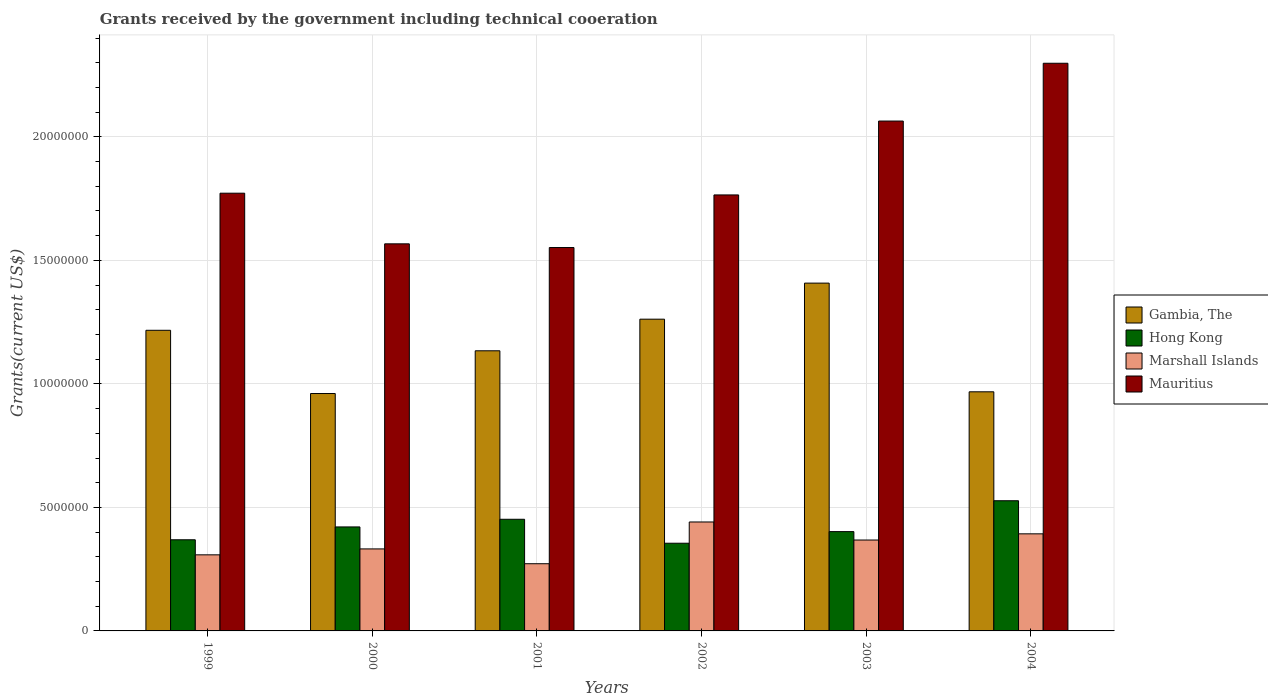Are the number of bars per tick equal to the number of legend labels?
Your response must be concise. Yes. How many bars are there on the 6th tick from the left?
Offer a terse response. 4. How many bars are there on the 6th tick from the right?
Your answer should be very brief. 4. In how many cases, is the number of bars for a given year not equal to the number of legend labels?
Keep it short and to the point. 0. What is the total grants received by the government in Mauritius in 2002?
Make the answer very short. 1.76e+07. Across all years, what is the maximum total grants received by the government in Mauritius?
Give a very brief answer. 2.30e+07. Across all years, what is the minimum total grants received by the government in Marshall Islands?
Your response must be concise. 2.72e+06. In which year was the total grants received by the government in Hong Kong minimum?
Offer a very short reply. 2002. What is the total total grants received by the government in Gambia, The in the graph?
Make the answer very short. 6.95e+07. What is the difference between the total grants received by the government in Hong Kong in 1999 and that in 2001?
Provide a succinct answer. -8.30e+05. What is the difference between the total grants received by the government in Marshall Islands in 2000 and the total grants received by the government in Gambia, The in 2004?
Your answer should be very brief. -6.36e+06. What is the average total grants received by the government in Gambia, The per year?
Offer a terse response. 1.16e+07. In the year 2003, what is the difference between the total grants received by the government in Gambia, The and total grants received by the government in Hong Kong?
Make the answer very short. 1.01e+07. In how many years, is the total grants received by the government in Mauritius greater than 17000000 US$?
Your answer should be compact. 4. What is the ratio of the total grants received by the government in Gambia, The in 2002 to that in 2003?
Provide a short and direct response. 0.9. What is the difference between the highest and the second highest total grants received by the government in Hong Kong?
Your answer should be compact. 7.50e+05. What is the difference between the highest and the lowest total grants received by the government in Hong Kong?
Provide a succinct answer. 1.72e+06. In how many years, is the total grants received by the government in Gambia, The greater than the average total grants received by the government in Gambia, The taken over all years?
Offer a terse response. 3. Is it the case that in every year, the sum of the total grants received by the government in Hong Kong and total grants received by the government in Mauritius is greater than the sum of total grants received by the government in Gambia, The and total grants received by the government in Marshall Islands?
Offer a very short reply. Yes. What does the 1st bar from the left in 1999 represents?
Offer a terse response. Gambia, The. What does the 4th bar from the right in 2001 represents?
Your answer should be very brief. Gambia, The. Is it the case that in every year, the sum of the total grants received by the government in Gambia, The and total grants received by the government in Marshall Islands is greater than the total grants received by the government in Mauritius?
Ensure brevity in your answer.  No. What is the difference between two consecutive major ticks on the Y-axis?
Offer a very short reply. 5.00e+06. Does the graph contain any zero values?
Ensure brevity in your answer.  No. Where does the legend appear in the graph?
Ensure brevity in your answer.  Center right. How are the legend labels stacked?
Give a very brief answer. Vertical. What is the title of the graph?
Your response must be concise. Grants received by the government including technical cooeration. Does "High income" appear as one of the legend labels in the graph?
Make the answer very short. No. What is the label or title of the X-axis?
Provide a succinct answer. Years. What is the label or title of the Y-axis?
Offer a terse response. Grants(current US$). What is the Grants(current US$) of Gambia, The in 1999?
Make the answer very short. 1.22e+07. What is the Grants(current US$) of Hong Kong in 1999?
Your response must be concise. 3.69e+06. What is the Grants(current US$) of Marshall Islands in 1999?
Offer a terse response. 3.08e+06. What is the Grants(current US$) in Mauritius in 1999?
Make the answer very short. 1.77e+07. What is the Grants(current US$) of Gambia, The in 2000?
Your answer should be very brief. 9.61e+06. What is the Grants(current US$) in Hong Kong in 2000?
Your answer should be compact. 4.21e+06. What is the Grants(current US$) of Marshall Islands in 2000?
Provide a short and direct response. 3.32e+06. What is the Grants(current US$) of Mauritius in 2000?
Your answer should be compact. 1.57e+07. What is the Grants(current US$) of Gambia, The in 2001?
Give a very brief answer. 1.13e+07. What is the Grants(current US$) in Hong Kong in 2001?
Your answer should be compact. 4.52e+06. What is the Grants(current US$) of Marshall Islands in 2001?
Keep it short and to the point. 2.72e+06. What is the Grants(current US$) of Mauritius in 2001?
Your response must be concise. 1.55e+07. What is the Grants(current US$) in Gambia, The in 2002?
Give a very brief answer. 1.26e+07. What is the Grants(current US$) of Hong Kong in 2002?
Your response must be concise. 3.55e+06. What is the Grants(current US$) of Marshall Islands in 2002?
Offer a terse response. 4.41e+06. What is the Grants(current US$) of Mauritius in 2002?
Your answer should be very brief. 1.76e+07. What is the Grants(current US$) of Gambia, The in 2003?
Make the answer very short. 1.41e+07. What is the Grants(current US$) in Hong Kong in 2003?
Make the answer very short. 4.02e+06. What is the Grants(current US$) in Marshall Islands in 2003?
Offer a terse response. 3.68e+06. What is the Grants(current US$) in Mauritius in 2003?
Keep it short and to the point. 2.06e+07. What is the Grants(current US$) in Gambia, The in 2004?
Provide a succinct answer. 9.68e+06. What is the Grants(current US$) in Hong Kong in 2004?
Make the answer very short. 5.27e+06. What is the Grants(current US$) of Marshall Islands in 2004?
Keep it short and to the point. 3.93e+06. What is the Grants(current US$) of Mauritius in 2004?
Your answer should be compact. 2.30e+07. Across all years, what is the maximum Grants(current US$) in Gambia, The?
Your answer should be very brief. 1.41e+07. Across all years, what is the maximum Grants(current US$) of Hong Kong?
Give a very brief answer. 5.27e+06. Across all years, what is the maximum Grants(current US$) of Marshall Islands?
Your answer should be very brief. 4.41e+06. Across all years, what is the maximum Grants(current US$) in Mauritius?
Provide a succinct answer. 2.30e+07. Across all years, what is the minimum Grants(current US$) in Gambia, The?
Ensure brevity in your answer.  9.61e+06. Across all years, what is the minimum Grants(current US$) in Hong Kong?
Give a very brief answer. 3.55e+06. Across all years, what is the minimum Grants(current US$) in Marshall Islands?
Ensure brevity in your answer.  2.72e+06. Across all years, what is the minimum Grants(current US$) of Mauritius?
Offer a very short reply. 1.55e+07. What is the total Grants(current US$) of Gambia, The in the graph?
Make the answer very short. 6.95e+07. What is the total Grants(current US$) in Hong Kong in the graph?
Provide a succinct answer. 2.53e+07. What is the total Grants(current US$) of Marshall Islands in the graph?
Ensure brevity in your answer.  2.11e+07. What is the total Grants(current US$) of Mauritius in the graph?
Your answer should be very brief. 1.10e+08. What is the difference between the Grants(current US$) in Gambia, The in 1999 and that in 2000?
Make the answer very short. 2.56e+06. What is the difference between the Grants(current US$) in Hong Kong in 1999 and that in 2000?
Your answer should be compact. -5.20e+05. What is the difference between the Grants(current US$) of Mauritius in 1999 and that in 2000?
Your answer should be compact. 2.05e+06. What is the difference between the Grants(current US$) in Gambia, The in 1999 and that in 2001?
Offer a very short reply. 8.30e+05. What is the difference between the Grants(current US$) in Hong Kong in 1999 and that in 2001?
Provide a succinct answer. -8.30e+05. What is the difference between the Grants(current US$) of Mauritius in 1999 and that in 2001?
Keep it short and to the point. 2.20e+06. What is the difference between the Grants(current US$) in Gambia, The in 1999 and that in 2002?
Ensure brevity in your answer.  -4.50e+05. What is the difference between the Grants(current US$) of Hong Kong in 1999 and that in 2002?
Make the answer very short. 1.40e+05. What is the difference between the Grants(current US$) in Marshall Islands in 1999 and that in 2002?
Your answer should be very brief. -1.33e+06. What is the difference between the Grants(current US$) of Mauritius in 1999 and that in 2002?
Keep it short and to the point. 7.00e+04. What is the difference between the Grants(current US$) in Gambia, The in 1999 and that in 2003?
Offer a terse response. -1.91e+06. What is the difference between the Grants(current US$) of Hong Kong in 1999 and that in 2003?
Your answer should be compact. -3.30e+05. What is the difference between the Grants(current US$) in Marshall Islands in 1999 and that in 2003?
Your answer should be very brief. -6.00e+05. What is the difference between the Grants(current US$) of Mauritius in 1999 and that in 2003?
Provide a succinct answer. -2.92e+06. What is the difference between the Grants(current US$) in Gambia, The in 1999 and that in 2004?
Your answer should be compact. 2.49e+06. What is the difference between the Grants(current US$) in Hong Kong in 1999 and that in 2004?
Give a very brief answer. -1.58e+06. What is the difference between the Grants(current US$) of Marshall Islands in 1999 and that in 2004?
Provide a short and direct response. -8.50e+05. What is the difference between the Grants(current US$) of Mauritius in 1999 and that in 2004?
Your answer should be very brief. -5.26e+06. What is the difference between the Grants(current US$) of Gambia, The in 2000 and that in 2001?
Provide a short and direct response. -1.73e+06. What is the difference between the Grants(current US$) in Hong Kong in 2000 and that in 2001?
Give a very brief answer. -3.10e+05. What is the difference between the Grants(current US$) in Marshall Islands in 2000 and that in 2001?
Keep it short and to the point. 6.00e+05. What is the difference between the Grants(current US$) of Mauritius in 2000 and that in 2001?
Give a very brief answer. 1.50e+05. What is the difference between the Grants(current US$) in Gambia, The in 2000 and that in 2002?
Make the answer very short. -3.01e+06. What is the difference between the Grants(current US$) in Marshall Islands in 2000 and that in 2002?
Your answer should be compact. -1.09e+06. What is the difference between the Grants(current US$) in Mauritius in 2000 and that in 2002?
Keep it short and to the point. -1.98e+06. What is the difference between the Grants(current US$) in Gambia, The in 2000 and that in 2003?
Offer a very short reply. -4.47e+06. What is the difference between the Grants(current US$) in Marshall Islands in 2000 and that in 2003?
Ensure brevity in your answer.  -3.60e+05. What is the difference between the Grants(current US$) of Mauritius in 2000 and that in 2003?
Your answer should be compact. -4.97e+06. What is the difference between the Grants(current US$) of Hong Kong in 2000 and that in 2004?
Provide a succinct answer. -1.06e+06. What is the difference between the Grants(current US$) in Marshall Islands in 2000 and that in 2004?
Give a very brief answer. -6.10e+05. What is the difference between the Grants(current US$) of Mauritius in 2000 and that in 2004?
Offer a very short reply. -7.31e+06. What is the difference between the Grants(current US$) of Gambia, The in 2001 and that in 2002?
Keep it short and to the point. -1.28e+06. What is the difference between the Grants(current US$) in Hong Kong in 2001 and that in 2002?
Provide a succinct answer. 9.70e+05. What is the difference between the Grants(current US$) in Marshall Islands in 2001 and that in 2002?
Make the answer very short. -1.69e+06. What is the difference between the Grants(current US$) of Mauritius in 2001 and that in 2002?
Your response must be concise. -2.13e+06. What is the difference between the Grants(current US$) of Gambia, The in 2001 and that in 2003?
Your answer should be very brief. -2.74e+06. What is the difference between the Grants(current US$) in Marshall Islands in 2001 and that in 2003?
Keep it short and to the point. -9.60e+05. What is the difference between the Grants(current US$) in Mauritius in 2001 and that in 2003?
Provide a short and direct response. -5.12e+06. What is the difference between the Grants(current US$) of Gambia, The in 2001 and that in 2004?
Offer a very short reply. 1.66e+06. What is the difference between the Grants(current US$) in Hong Kong in 2001 and that in 2004?
Your response must be concise. -7.50e+05. What is the difference between the Grants(current US$) in Marshall Islands in 2001 and that in 2004?
Your response must be concise. -1.21e+06. What is the difference between the Grants(current US$) of Mauritius in 2001 and that in 2004?
Your answer should be very brief. -7.46e+06. What is the difference between the Grants(current US$) of Gambia, The in 2002 and that in 2003?
Your response must be concise. -1.46e+06. What is the difference between the Grants(current US$) of Hong Kong in 2002 and that in 2003?
Your answer should be very brief. -4.70e+05. What is the difference between the Grants(current US$) of Marshall Islands in 2002 and that in 2003?
Your answer should be very brief. 7.30e+05. What is the difference between the Grants(current US$) in Mauritius in 2002 and that in 2003?
Give a very brief answer. -2.99e+06. What is the difference between the Grants(current US$) in Gambia, The in 2002 and that in 2004?
Make the answer very short. 2.94e+06. What is the difference between the Grants(current US$) in Hong Kong in 2002 and that in 2004?
Provide a short and direct response. -1.72e+06. What is the difference between the Grants(current US$) of Mauritius in 2002 and that in 2004?
Provide a succinct answer. -5.33e+06. What is the difference between the Grants(current US$) of Gambia, The in 2003 and that in 2004?
Keep it short and to the point. 4.40e+06. What is the difference between the Grants(current US$) in Hong Kong in 2003 and that in 2004?
Your answer should be compact. -1.25e+06. What is the difference between the Grants(current US$) in Marshall Islands in 2003 and that in 2004?
Your response must be concise. -2.50e+05. What is the difference between the Grants(current US$) in Mauritius in 2003 and that in 2004?
Keep it short and to the point. -2.34e+06. What is the difference between the Grants(current US$) in Gambia, The in 1999 and the Grants(current US$) in Hong Kong in 2000?
Your answer should be compact. 7.96e+06. What is the difference between the Grants(current US$) in Gambia, The in 1999 and the Grants(current US$) in Marshall Islands in 2000?
Give a very brief answer. 8.85e+06. What is the difference between the Grants(current US$) in Gambia, The in 1999 and the Grants(current US$) in Mauritius in 2000?
Ensure brevity in your answer.  -3.50e+06. What is the difference between the Grants(current US$) in Hong Kong in 1999 and the Grants(current US$) in Marshall Islands in 2000?
Provide a short and direct response. 3.70e+05. What is the difference between the Grants(current US$) in Hong Kong in 1999 and the Grants(current US$) in Mauritius in 2000?
Provide a succinct answer. -1.20e+07. What is the difference between the Grants(current US$) of Marshall Islands in 1999 and the Grants(current US$) of Mauritius in 2000?
Your answer should be very brief. -1.26e+07. What is the difference between the Grants(current US$) in Gambia, The in 1999 and the Grants(current US$) in Hong Kong in 2001?
Make the answer very short. 7.65e+06. What is the difference between the Grants(current US$) in Gambia, The in 1999 and the Grants(current US$) in Marshall Islands in 2001?
Offer a very short reply. 9.45e+06. What is the difference between the Grants(current US$) in Gambia, The in 1999 and the Grants(current US$) in Mauritius in 2001?
Provide a short and direct response. -3.35e+06. What is the difference between the Grants(current US$) of Hong Kong in 1999 and the Grants(current US$) of Marshall Islands in 2001?
Offer a terse response. 9.70e+05. What is the difference between the Grants(current US$) in Hong Kong in 1999 and the Grants(current US$) in Mauritius in 2001?
Provide a succinct answer. -1.18e+07. What is the difference between the Grants(current US$) in Marshall Islands in 1999 and the Grants(current US$) in Mauritius in 2001?
Your answer should be compact. -1.24e+07. What is the difference between the Grants(current US$) of Gambia, The in 1999 and the Grants(current US$) of Hong Kong in 2002?
Give a very brief answer. 8.62e+06. What is the difference between the Grants(current US$) in Gambia, The in 1999 and the Grants(current US$) in Marshall Islands in 2002?
Your answer should be very brief. 7.76e+06. What is the difference between the Grants(current US$) in Gambia, The in 1999 and the Grants(current US$) in Mauritius in 2002?
Your response must be concise. -5.48e+06. What is the difference between the Grants(current US$) of Hong Kong in 1999 and the Grants(current US$) of Marshall Islands in 2002?
Offer a very short reply. -7.20e+05. What is the difference between the Grants(current US$) in Hong Kong in 1999 and the Grants(current US$) in Mauritius in 2002?
Make the answer very short. -1.40e+07. What is the difference between the Grants(current US$) in Marshall Islands in 1999 and the Grants(current US$) in Mauritius in 2002?
Make the answer very short. -1.46e+07. What is the difference between the Grants(current US$) of Gambia, The in 1999 and the Grants(current US$) of Hong Kong in 2003?
Provide a succinct answer. 8.15e+06. What is the difference between the Grants(current US$) of Gambia, The in 1999 and the Grants(current US$) of Marshall Islands in 2003?
Ensure brevity in your answer.  8.49e+06. What is the difference between the Grants(current US$) in Gambia, The in 1999 and the Grants(current US$) in Mauritius in 2003?
Offer a terse response. -8.47e+06. What is the difference between the Grants(current US$) of Hong Kong in 1999 and the Grants(current US$) of Marshall Islands in 2003?
Offer a very short reply. 10000. What is the difference between the Grants(current US$) in Hong Kong in 1999 and the Grants(current US$) in Mauritius in 2003?
Your answer should be very brief. -1.70e+07. What is the difference between the Grants(current US$) in Marshall Islands in 1999 and the Grants(current US$) in Mauritius in 2003?
Ensure brevity in your answer.  -1.76e+07. What is the difference between the Grants(current US$) in Gambia, The in 1999 and the Grants(current US$) in Hong Kong in 2004?
Provide a short and direct response. 6.90e+06. What is the difference between the Grants(current US$) of Gambia, The in 1999 and the Grants(current US$) of Marshall Islands in 2004?
Provide a short and direct response. 8.24e+06. What is the difference between the Grants(current US$) in Gambia, The in 1999 and the Grants(current US$) in Mauritius in 2004?
Offer a terse response. -1.08e+07. What is the difference between the Grants(current US$) in Hong Kong in 1999 and the Grants(current US$) in Marshall Islands in 2004?
Ensure brevity in your answer.  -2.40e+05. What is the difference between the Grants(current US$) in Hong Kong in 1999 and the Grants(current US$) in Mauritius in 2004?
Offer a very short reply. -1.93e+07. What is the difference between the Grants(current US$) of Marshall Islands in 1999 and the Grants(current US$) of Mauritius in 2004?
Your answer should be compact. -1.99e+07. What is the difference between the Grants(current US$) of Gambia, The in 2000 and the Grants(current US$) of Hong Kong in 2001?
Make the answer very short. 5.09e+06. What is the difference between the Grants(current US$) in Gambia, The in 2000 and the Grants(current US$) in Marshall Islands in 2001?
Keep it short and to the point. 6.89e+06. What is the difference between the Grants(current US$) of Gambia, The in 2000 and the Grants(current US$) of Mauritius in 2001?
Offer a very short reply. -5.91e+06. What is the difference between the Grants(current US$) of Hong Kong in 2000 and the Grants(current US$) of Marshall Islands in 2001?
Give a very brief answer. 1.49e+06. What is the difference between the Grants(current US$) in Hong Kong in 2000 and the Grants(current US$) in Mauritius in 2001?
Your response must be concise. -1.13e+07. What is the difference between the Grants(current US$) of Marshall Islands in 2000 and the Grants(current US$) of Mauritius in 2001?
Your response must be concise. -1.22e+07. What is the difference between the Grants(current US$) of Gambia, The in 2000 and the Grants(current US$) of Hong Kong in 2002?
Offer a very short reply. 6.06e+06. What is the difference between the Grants(current US$) in Gambia, The in 2000 and the Grants(current US$) in Marshall Islands in 2002?
Keep it short and to the point. 5.20e+06. What is the difference between the Grants(current US$) of Gambia, The in 2000 and the Grants(current US$) of Mauritius in 2002?
Make the answer very short. -8.04e+06. What is the difference between the Grants(current US$) of Hong Kong in 2000 and the Grants(current US$) of Marshall Islands in 2002?
Ensure brevity in your answer.  -2.00e+05. What is the difference between the Grants(current US$) in Hong Kong in 2000 and the Grants(current US$) in Mauritius in 2002?
Keep it short and to the point. -1.34e+07. What is the difference between the Grants(current US$) in Marshall Islands in 2000 and the Grants(current US$) in Mauritius in 2002?
Offer a very short reply. -1.43e+07. What is the difference between the Grants(current US$) of Gambia, The in 2000 and the Grants(current US$) of Hong Kong in 2003?
Make the answer very short. 5.59e+06. What is the difference between the Grants(current US$) of Gambia, The in 2000 and the Grants(current US$) of Marshall Islands in 2003?
Ensure brevity in your answer.  5.93e+06. What is the difference between the Grants(current US$) in Gambia, The in 2000 and the Grants(current US$) in Mauritius in 2003?
Offer a terse response. -1.10e+07. What is the difference between the Grants(current US$) of Hong Kong in 2000 and the Grants(current US$) of Marshall Islands in 2003?
Your response must be concise. 5.30e+05. What is the difference between the Grants(current US$) in Hong Kong in 2000 and the Grants(current US$) in Mauritius in 2003?
Your answer should be very brief. -1.64e+07. What is the difference between the Grants(current US$) of Marshall Islands in 2000 and the Grants(current US$) of Mauritius in 2003?
Offer a terse response. -1.73e+07. What is the difference between the Grants(current US$) of Gambia, The in 2000 and the Grants(current US$) of Hong Kong in 2004?
Your answer should be compact. 4.34e+06. What is the difference between the Grants(current US$) of Gambia, The in 2000 and the Grants(current US$) of Marshall Islands in 2004?
Your answer should be very brief. 5.68e+06. What is the difference between the Grants(current US$) of Gambia, The in 2000 and the Grants(current US$) of Mauritius in 2004?
Give a very brief answer. -1.34e+07. What is the difference between the Grants(current US$) of Hong Kong in 2000 and the Grants(current US$) of Marshall Islands in 2004?
Keep it short and to the point. 2.80e+05. What is the difference between the Grants(current US$) in Hong Kong in 2000 and the Grants(current US$) in Mauritius in 2004?
Your answer should be very brief. -1.88e+07. What is the difference between the Grants(current US$) of Marshall Islands in 2000 and the Grants(current US$) of Mauritius in 2004?
Make the answer very short. -1.97e+07. What is the difference between the Grants(current US$) in Gambia, The in 2001 and the Grants(current US$) in Hong Kong in 2002?
Offer a terse response. 7.79e+06. What is the difference between the Grants(current US$) of Gambia, The in 2001 and the Grants(current US$) of Marshall Islands in 2002?
Keep it short and to the point. 6.93e+06. What is the difference between the Grants(current US$) in Gambia, The in 2001 and the Grants(current US$) in Mauritius in 2002?
Provide a succinct answer. -6.31e+06. What is the difference between the Grants(current US$) of Hong Kong in 2001 and the Grants(current US$) of Mauritius in 2002?
Keep it short and to the point. -1.31e+07. What is the difference between the Grants(current US$) of Marshall Islands in 2001 and the Grants(current US$) of Mauritius in 2002?
Keep it short and to the point. -1.49e+07. What is the difference between the Grants(current US$) of Gambia, The in 2001 and the Grants(current US$) of Hong Kong in 2003?
Keep it short and to the point. 7.32e+06. What is the difference between the Grants(current US$) of Gambia, The in 2001 and the Grants(current US$) of Marshall Islands in 2003?
Your response must be concise. 7.66e+06. What is the difference between the Grants(current US$) in Gambia, The in 2001 and the Grants(current US$) in Mauritius in 2003?
Provide a succinct answer. -9.30e+06. What is the difference between the Grants(current US$) in Hong Kong in 2001 and the Grants(current US$) in Marshall Islands in 2003?
Offer a terse response. 8.40e+05. What is the difference between the Grants(current US$) in Hong Kong in 2001 and the Grants(current US$) in Mauritius in 2003?
Offer a very short reply. -1.61e+07. What is the difference between the Grants(current US$) in Marshall Islands in 2001 and the Grants(current US$) in Mauritius in 2003?
Keep it short and to the point. -1.79e+07. What is the difference between the Grants(current US$) of Gambia, The in 2001 and the Grants(current US$) of Hong Kong in 2004?
Provide a short and direct response. 6.07e+06. What is the difference between the Grants(current US$) in Gambia, The in 2001 and the Grants(current US$) in Marshall Islands in 2004?
Provide a short and direct response. 7.41e+06. What is the difference between the Grants(current US$) in Gambia, The in 2001 and the Grants(current US$) in Mauritius in 2004?
Your answer should be very brief. -1.16e+07. What is the difference between the Grants(current US$) of Hong Kong in 2001 and the Grants(current US$) of Marshall Islands in 2004?
Provide a short and direct response. 5.90e+05. What is the difference between the Grants(current US$) of Hong Kong in 2001 and the Grants(current US$) of Mauritius in 2004?
Give a very brief answer. -1.85e+07. What is the difference between the Grants(current US$) in Marshall Islands in 2001 and the Grants(current US$) in Mauritius in 2004?
Offer a very short reply. -2.03e+07. What is the difference between the Grants(current US$) in Gambia, The in 2002 and the Grants(current US$) in Hong Kong in 2003?
Provide a short and direct response. 8.60e+06. What is the difference between the Grants(current US$) of Gambia, The in 2002 and the Grants(current US$) of Marshall Islands in 2003?
Keep it short and to the point. 8.94e+06. What is the difference between the Grants(current US$) in Gambia, The in 2002 and the Grants(current US$) in Mauritius in 2003?
Offer a very short reply. -8.02e+06. What is the difference between the Grants(current US$) of Hong Kong in 2002 and the Grants(current US$) of Marshall Islands in 2003?
Provide a succinct answer. -1.30e+05. What is the difference between the Grants(current US$) of Hong Kong in 2002 and the Grants(current US$) of Mauritius in 2003?
Provide a short and direct response. -1.71e+07. What is the difference between the Grants(current US$) of Marshall Islands in 2002 and the Grants(current US$) of Mauritius in 2003?
Offer a very short reply. -1.62e+07. What is the difference between the Grants(current US$) in Gambia, The in 2002 and the Grants(current US$) in Hong Kong in 2004?
Your answer should be very brief. 7.35e+06. What is the difference between the Grants(current US$) in Gambia, The in 2002 and the Grants(current US$) in Marshall Islands in 2004?
Give a very brief answer. 8.69e+06. What is the difference between the Grants(current US$) in Gambia, The in 2002 and the Grants(current US$) in Mauritius in 2004?
Provide a short and direct response. -1.04e+07. What is the difference between the Grants(current US$) in Hong Kong in 2002 and the Grants(current US$) in Marshall Islands in 2004?
Provide a succinct answer. -3.80e+05. What is the difference between the Grants(current US$) of Hong Kong in 2002 and the Grants(current US$) of Mauritius in 2004?
Offer a terse response. -1.94e+07. What is the difference between the Grants(current US$) of Marshall Islands in 2002 and the Grants(current US$) of Mauritius in 2004?
Offer a terse response. -1.86e+07. What is the difference between the Grants(current US$) of Gambia, The in 2003 and the Grants(current US$) of Hong Kong in 2004?
Your answer should be compact. 8.81e+06. What is the difference between the Grants(current US$) in Gambia, The in 2003 and the Grants(current US$) in Marshall Islands in 2004?
Offer a terse response. 1.02e+07. What is the difference between the Grants(current US$) in Gambia, The in 2003 and the Grants(current US$) in Mauritius in 2004?
Provide a succinct answer. -8.90e+06. What is the difference between the Grants(current US$) in Hong Kong in 2003 and the Grants(current US$) in Mauritius in 2004?
Give a very brief answer. -1.90e+07. What is the difference between the Grants(current US$) of Marshall Islands in 2003 and the Grants(current US$) of Mauritius in 2004?
Offer a very short reply. -1.93e+07. What is the average Grants(current US$) in Gambia, The per year?
Provide a short and direct response. 1.16e+07. What is the average Grants(current US$) in Hong Kong per year?
Ensure brevity in your answer.  4.21e+06. What is the average Grants(current US$) of Marshall Islands per year?
Your answer should be very brief. 3.52e+06. What is the average Grants(current US$) of Mauritius per year?
Offer a terse response. 1.84e+07. In the year 1999, what is the difference between the Grants(current US$) in Gambia, The and Grants(current US$) in Hong Kong?
Offer a terse response. 8.48e+06. In the year 1999, what is the difference between the Grants(current US$) in Gambia, The and Grants(current US$) in Marshall Islands?
Ensure brevity in your answer.  9.09e+06. In the year 1999, what is the difference between the Grants(current US$) in Gambia, The and Grants(current US$) in Mauritius?
Your answer should be very brief. -5.55e+06. In the year 1999, what is the difference between the Grants(current US$) of Hong Kong and Grants(current US$) of Mauritius?
Your response must be concise. -1.40e+07. In the year 1999, what is the difference between the Grants(current US$) in Marshall Islands and Grants(current US$) in Mauritius?
Ensure brevity in your answer.  -1.46e+07. In the year 2000, what is the difference between the Grants(current US$) in Gambia, The and Grants(current US$) in Hong Kong?
Ensure brevity in your answer.  5.40e+06. In the year 2000, what is the difference between the Grants(current US$) in Gambia, The and Grants(current US$) in Marshall Islands?
Your answer should be compact. 6.29e+06. In the year 2000, what is the difference between the Grants(current US$) of Gambia, The and Grants(current US$) of Mauritius?
Make the answer very short. -6.06e+06. In the year 2000, what is the difference between the Grants(current US$) in Hong Kong and Grants(current US$) in Marshall Islands?
Your answer should be compact. 8.90e+05. In the year 2000, what is the difference between the Grants(current US$) of Hong Kong and Grants(current US$) of Mauritius?
Give a very brief answer. -1.15e+07. In the year 2000, what is the difference between the Grants(current US$) in Marshall Islands and Grants(current US$) in Mauritius?
Offer a very short reply. -1.24e+07. In the year 2001, what is the difference between the Grants(current US$) of Gambia, The and Grants(current US$) of Hong Kong?
Offer a very short reply. 6.82e+06. In the year 2001, what is the difference between the Grants(current US$) in Gambia, The and Grants(current US$) in Marshall Islands?
Your answer should be very brief. 8.62e+06. In the year 2001, what is the difference between the Grants(current US$) of Gambia, The and Grants(current US$) of Mauritius?
Your answer should be very brief. -4.18e+06. In the year 2001, what is the difference between the Grants(current US$) in Hong Kong and Grants(current US$) in Marshall Islands?
Ensure brevity in your answer.  1.80e+06. In the year 2001, what is the difference between the Grants(current US$) in Hong Kong and Grants(current US$) in Mauritius?
Your answer should be compact. -1.10e+07. In the year 2001, what is the difference between the Grants(current US$) of Marshall Islands and Grants(current US$) of Mauritius?
Make the answer very short. -1.28e+07. In the year 2002, what is the difference between the Grants(current US$) of Gambia, The and Grants(current US$) of Hong Kong?
Your answer should be very brief. 9.07e+06. In the year 2002, what is the difference between the Grants(current US$) in Gambia, The and Grants(current US$) in Marshall Islands?
Make the answer very short. 8.21e+06. In the year 2002, what is the difference between the Grants(current US$) of Gambia, The and Grants(current US$) of Mauritius?
Ensure brevity in your answer.  -5.03e+06. In the year 2002, what is the difference between the Grants(current US$) of Hong Kong and Grants(current US$) of Marshall Islands?
Provide a succinct answer. -8.60e+05. In the year 2002, what is the difference between the Grants(current US$) in Hong Kong and Grants(current US$) in Mauritius?
Ensure brevity in your answer.  -1.41e+07. In the year 2002, what is the difference between the Grants(current US$) in Marshall Islands and Grants(current US$) in Mauritius?
Your response must be concise. -1.32e+07. In the year 2003, what is the difference between the Grants(current US$) in Gambia, The and Grants(current US$) in Hong Kong?
Provide a succinct answer. 1.01e+07. In the year 2003, what is the difference between the Grants(current US$) of Gambia, The and Grants(current US$) of Marshall Islands?
Give a very brief answer. 1.04e+07. In the year 2003, what is the difference between the Grants(current US$) in Gambia, The and Grants(current US$) in Mauritius?
Give a very brief answer. -6.56e+06. In the year 2003, what is the difference between the Grants(current US$) in Hong Kong and Grants(current US$) in Mauritius?
Your answer should be very brief. -1.66e+07. In the year 2003, what is the difference between the Grants(current US$) in Marshall Islands and Grants(current US$) in Mauritius?
Offer a terse response. -1.70e+07. In the year 2004, what is the difference between the Grants(current US$) of Gambia, The and Grants(current US$) of Hong Kong?
Offer a very short reply. 4.41e+06. In the year 2004, what is the difference between the Grants(current US$) in Gambia, The and Grants(current US$) in Marshall Islands?
Offer a terse response. 5.75e+06. In the year 2004, what is the difference between the Grants(current US$) in Gambia, The and Grants(current US$) in Mauritius?
Your answer should be compact. -1.33e+07. In the year 2004, what is the difference between the Grants(current US$) of Hong Kong and Grants(current US$) of Marshall Islands?
Provide a short and direct response. 1.34e+06. In the year 2004, what is the difference between the Grants(current US$) in Hong Kong and Grants(current US$) in Mauritius?
Your answer should be compact. -1.77e+07. In the year 2004, what is the difference between the Grants(current US$) in Marshall Islands and Grants(current US$) in Mauritius?
Your answer should be compact. -1.90e+07. What is the ratio of the Grants(current US$) in Gambia, The in 1999 to that in 2000?
Your answer should be compact. 1.27. What is the ratio of the Grants(current US$) in Hong Kong in 1999 to that in 2000?
Make the answer very short. 0.88. What is the ratio of the Grants(current US$) of Marshall Islands in 1999 to that in 2000?
Provide a succinct answer. 0.93. What is the ratio of the Grants(current US$) in Mauritius in 1999 to that in 2000?
Your answer should be very brief. 1.13. What is the ratio of the Grants(current US$) in Gambia, The in 1999 to that in 2001?
Your answer should be very brief. 1.07. What is the ratio of the Grants(current US$) in Hong Kong in 1999 to that in 2001?
Ensure brevity in your answer.  0.82. What is the ratio of the Grants(current US$) of Marshall Islands in 1999 to that in 2001?
Ensure brevity in your answer.  1.13. What is the ratio of the Grants(current US$) of Mauritius in 1999 to that in 2001?
Make the answer very short. 1.14. What is the ratio of the Grants(current US$) in Gambia, The in 1999 to that in 2002?
Your answer should be compact. 0.96. What is the ratio of the Grants(current US$) of Hong Kong in 1999 to that in 2002?
Your response must be concise. 1.04. What is the ratio of the Grants(current US$) in Marshall Islands in 1999 to that in 2002?
Make the answer very short. 0.7. What is the ratio of the Grants(current US$) of Mauritius in 1999 to that in 2002?
Your answer should be very brief. 1. What is the ratio of the Grants(current US$) of Gambia, The in 1999 to that in 2003?
Your response must be concise. 0.86. What is the ratio of the Grants(current US$) in Hong Kong in 1999 to that in 2003?
Keep it short and to the point. 0.92. What is the ratio of the Grants(current US$) in Marshall Islands in 1999 to that in 2003?
Make the answer very short. 0.84. What is the ratio of the Grants(current US$) of Mauritius in 1999 to that in 2003?
Provide a short and direct response. 0.86. What is the ratio of the Grants(current US$) of Gambia, The in 1999 to that in 2004?
Your response must be concise. 1.26. What is the ratio of the Grants(current US$) of Hong Kong in 1999 to that in 2004?
Give a very brief answer. 0.7. What is the ratio of the Grants(current US$) of Marshall Islands in 1999 to that in 2004?
Make the answer very short. 0.78. What is the ratio of the Grants(current US$) in Mauritius in 1999 to that in 2004?
Provide a short and direct response. 0.77. What is the ratio of the Grants(current US$) in Gambia, The in 2000 to that in 2001?
Your answer should be compact. 0.85. What is the ratio of the Grants(current US$) of Hong Kong in 2000 to that in 2001?
Your response must be concise. 0.93. What is the ratio of the Grants(current US$) of Marshall Islands in 2000 to that in 2001?
Ensure brevity in your answer.  1.22. What is the ratio of the Grants(current US$) in Mauritius in 2000 to that in 2001?
Keep it short and to the point. 1.01. What is the ratio of the Grants(current US$) of Gambia, The in 2000 to that in 2002?
Your answer should be compact. 0.76. What is the ratio of the Grants(current US$) of Hong Kong in 2000 to that in 2002?
Your answer should be very brief. 1.19. What is the ratio of the Grants(current US$) of Marshall Islands in 2000 to that in 2002?
Offer a terse response. 0.75. What is the ratio of the Grants(current US$) of Mauritius in 2000 to that in 2002?
Ensure brevity in your answer.  0.89. What is the ratio of the Grants(current US$) of Gambia, The in 2000 to that in 2003?
Your response must be concise. 0.68. What is the ratio of the Grants(current US$) in Hong Kong in 2000 to that in 2003?
Make the answer very short. 1.05. What is the ratio of the Grants(current US$) of Marshall Islands in 2000 to that in 2003?
Provide a short and direct response. 0.9. What is the ratio of the Grants(current US$) of Mauritius in 2000 to that in 2003?
Make the answer very short. 0.76. What is the ratio of the Grants(current US$) in Hong Kong in 2000 to that in 2004?
Your answer should be compact. 0.8. What is the ratio of the Grants(current US$) of Marshall Islands in 2000 to that in 2004?
Provide a succinct answer. 0.84. What is the ratio of the Grants(current US$) of Mauritius in 2000 to that in 2004?
Give a very brief answer. 0.68. What is the ratio of the Grants(current US$) of Gambia, The in 2001 to that in 2002?
Ensure brevity in your answer.  0.9. What is the ratio of the Grants(current US$) in Hong Kong in 2001 to that in 2002?
Your response must be concise. 1.27. What is the ratio of the Grants(current US$) in Marshall Islands in 2001 to that in 2002?
Keep it short and to the point. 0.62. What is the ratio of the Grants(current US$) in Mauritius in 2001 to that in 2002?
Your answer should be very brief. 0.88. What is the ratio of the Grants(current US$) in Gambia, The in 2001 to that in 2003?
Give a very brief answer. 0.81. What is the ratio of the Grants(current US$) of Hong Kong in 2001 to that in 2003?
Your answer should be very brief. 1.12. What is the ratio of the Grants(current US$) in Marshall Islands in 2001 to that in 2003?
Ensure brevity in your answer.  0.74. What is the ratio of the Grants(current US$) in Mauritius in 2001 to that in 2003?
Make the answer very short. 0.75. What is the ratio of the Grants(current US$) of Gambia, The in 2001 to that in 2004?
Provide a succinct answer. 1.17. What is the ratio of the Grants(current US$) in Hong Kong in 2001 to that in 2004?
Give a very brief answer. 0.86. What is the ratio of the Grants(current US$) of Marshall Islands in 2001 to that in 2004?
Give a very brief answer. 0.69. What is the ratio of the Grants(current US$) of Mauritius in 2001 to that in 2004?
Ensure brevity in your answer.  0.68. What is the ratio of the Grants(current US$) of Gambia, The in 2002 to that in 2003?
Your answer should be compact. 0.9. What is the ratio of the Grants(current US$) in Hong Kong in 2002 to that in 2003?
Your answer should be compact. 0.88. What is the ratio of the Grants(current US$) in Marshall Islands in 2002 to that in 2003?
Your answer should be very brief. 1.2. What is the ratio of the Grants(current US$) of Mauritius in 2002 to that in 2003?
Keep it short and to the point. 0.86. What is the ratio of the Grants(current US$) in Gambia, The in 2002 to that in 2004?
Keep it short and to the point. 1.3. What is the ratio of the Grants(current US$) in Hong Kong in 2002 to that in 2004?
Give a very brief answer. 0.67. What is the ratio of the Grants(current US$) of Marshall Islands in 2002 to that in 2004?
Make the answer very short. 1.12. What is the ratio of the Grants(current US$) of Mauritius in 2002 to that in 2004?
Give a very brief answer. 0.77. What is the ratio of the Grants(current US$) in Gambia, The in 2003 to that in 2004?
Your response must be concise. 1.45. What is the ratio of the Grants(current US$) of Hong Kong in 2003 to that in 2004?
Provide a short and direct response. 0.76. What is the ratio of the Grants(current US$) of Marshall Islands in 2003 to that in 2004?
Make the answer very short. 0.94. What is the ratio of the Grants(current US$) in Mauritius in 2003 to that in 2004?
Your response must be concise. 0.9. What is the difference between the highest and the second highest Grants(current US$) in Gambia, The?
Your answer should be compact. 1.46e+06. What is the difference between the highest and the second highest Grants(current US$) in Hong Kong?
Provide a short and direct response. 7.50e+05. What is the difference between the highest and the second highest Grants(current US$) of Mauritius?
Provide a succinct answer. 2.34e+06. What is the difference between the highest and the lowest Grants(current US$) of Gambia, The?
Your answer should be compact. 4.47e+06. What is the difference between the highest and the lowest Grants(current US$) in Hong Kong?
Give a very brief answer. 1.72e+06. What is the difference between the highest and the lowest Grants(current US$) of Marshall Islands?
Give a very brief answer. 1.69e+06. What is the difference between the highest and the lowest Grants(current US$) of Mauritius?
Your answer should be very brief. 7.46e+06. 